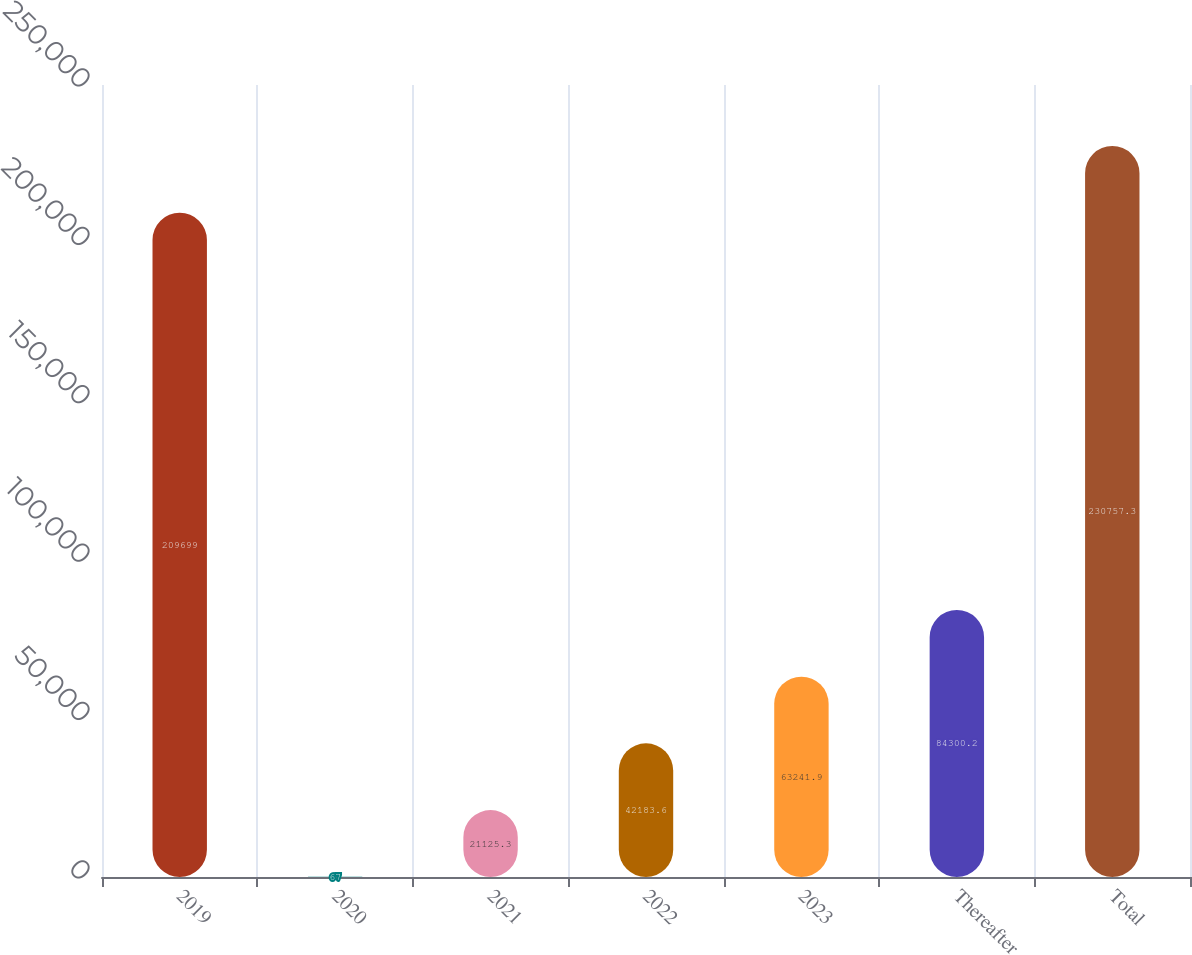Convert chart. <chart><loc_0><loc_0><loc_500><loc_500><bar_chart><fcel>2019<fcel>2020<fcel>2021<fcel>2022<fcel>2023<fcel>Thereafter<fcel>Total<nl><fcel>209699<fcel>67<fcel>21125.3<fcel>42183.6<fcel>63241.9<fcel>84300.2<fcel>230757<nl></chart> 